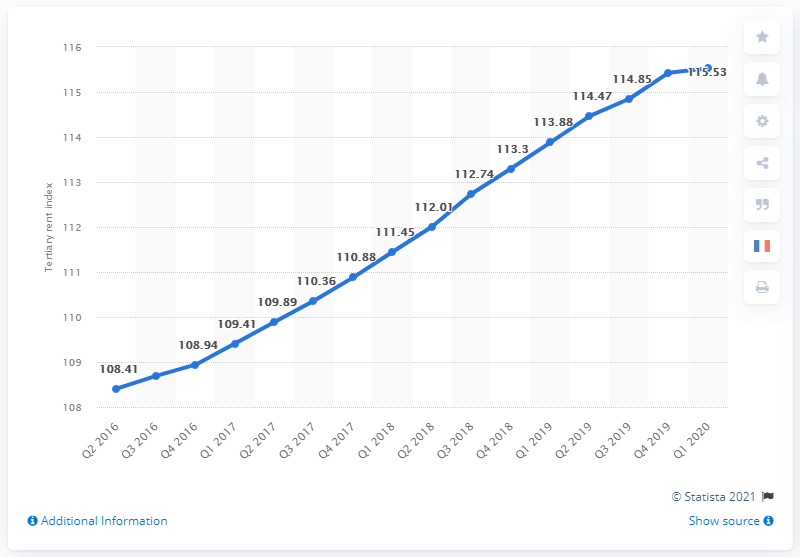Mention a couple of crucial points in this snapshot. The rent index for French tertiary activities in the first quarter of 2020 was 115.53. 